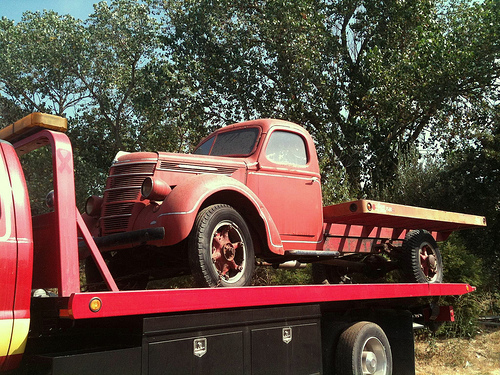<image>
Is the truck under the sky? Yes. The truck is positioned underneath the sky, with the sky above it in the vertical space. Is the truck behind the tree? No. The truck is not behind the tree. From this viewpoint, the truck appears to be positioned elsewhere in the scene. Is the vintage truck above the modern truck? No. The vintage truck is not positioned above the modern truck. The vertical arrangement shows a different relationship. 